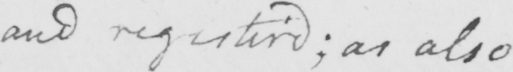Can you read and transcribe this handwriting? and registered ; as also 